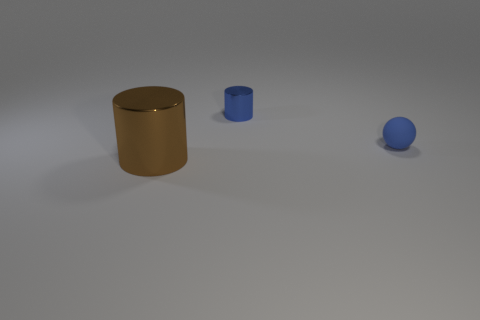What is the material of the cylinder that is the same color as the matte object?
Offer a very short reply. Metal. How many objects are objects that are in front of the matte sphere or objects that are behind the brown metal object?
Offer a very short reply. 3. Do the small shiny cylinder and the matte ball have the same color?
Your response must be concise. Yes. Is the number of big things less than the number of small purple cylinders?
Offer a very short reply. No. There is a large thing; are there any metal cylinders in front of it?
Offer a very short reply. No. Does the brown cylinder have the same material as the ball?
Keep it short and to the point. No. There is another small metal object that is the same shape as the brown shiny object; what color is it?
Give a very brief answer. Blue. There is a large cylinder that is on the left side of the small sphere; is its color the same as the tiny metallic cylinder?
Offer a terse response. No. There is a matte thing that is the same color as the tiny cylinder; what is its shape?
Provide a short and direct response. Sphere. What number of brown objects have the same material as the tiny sphere?
Your response must be concise. 0. 